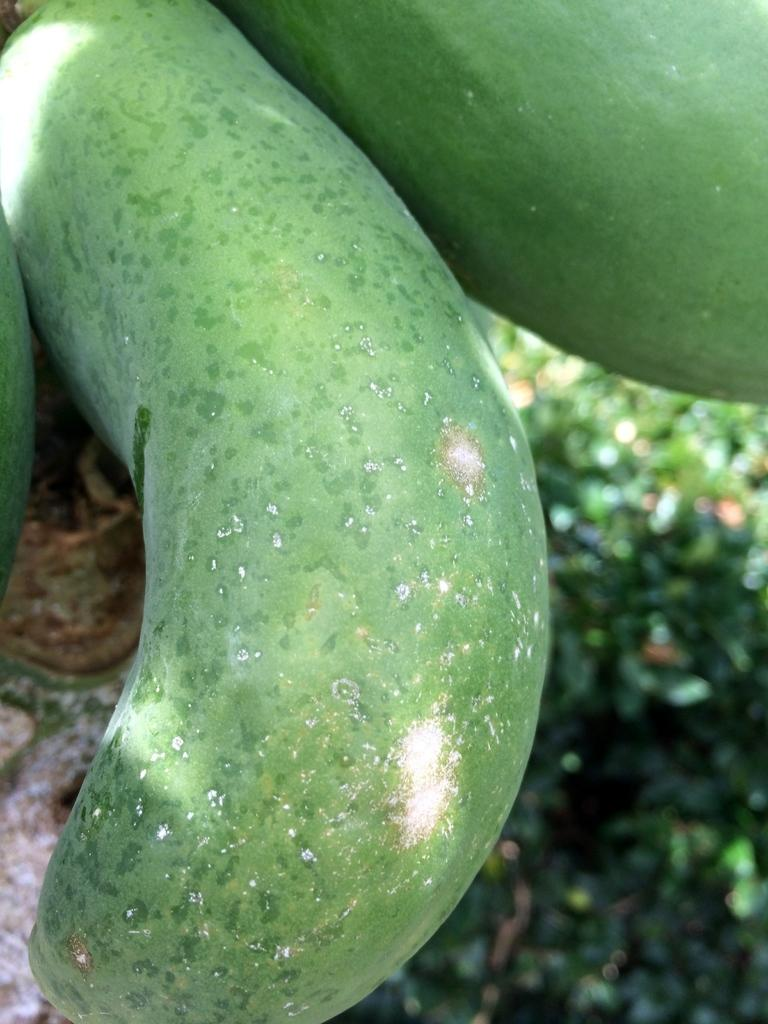What can be found in the image that is related to language? There are words in the image. What is the color of the words in the image? The words are in green color. What type of natural element is visible in the background of the image? There is a plant in the background of the image. What type of soup is being served in the image? There is no soup present in the image; it features words in green color and a plant in the background. Can you see any ants interacting with the words in the image? There are no ants present in the image. 